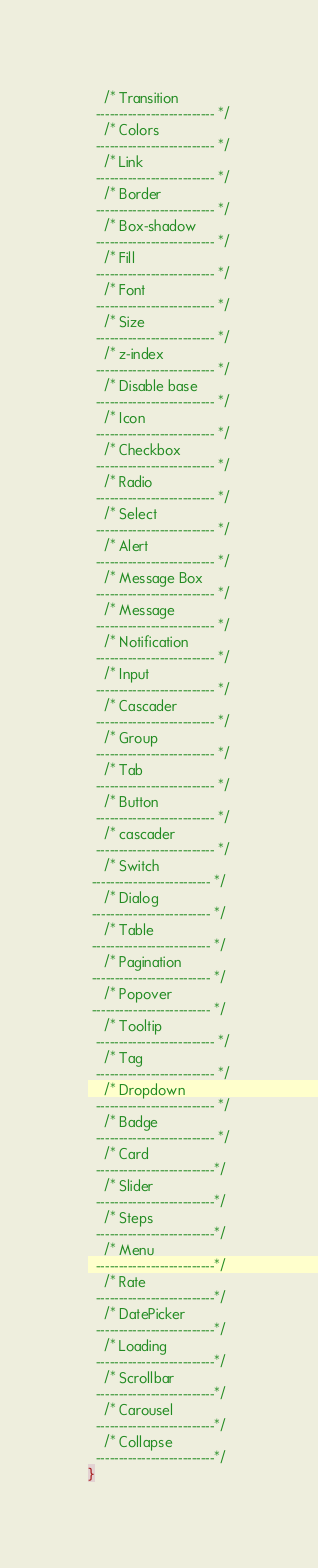Convert code to text. <code><loc_0><loc_0><loc_500><loc_500><_CSS_>    /* Transition
  -------------------------- */
    /* Colors
  -------------------------- */
    /* Link
  -------------------------- */
    /* Border
  -------------------------- */
    /* Box-shadow
  -------------------------- */
    /* Fill
  -------------------------- */
    /* Font
  -------------------------- */
    /* Size
  -------------------------- */
    /* z-index
  -------------------------- */
    /* Disable base
  -------------------------- */
    /* Icon
  -------------------------- */
    /* Checkbox
  -------------------------- */
    /* Radio
  -------------------------- */
    /* Select
  -------------------------- */
    /* Alert
  -------------------------- */
    /* Message Box
  -------------------------- */
    /* Message
  -------------------------- */
    /* Notification
  -------------------------- */
    /* Input
  -------------------------- */
    /* Cascader
  -------------------------- */
    /* Group
  -------------------------- */
    /* Tab
  -------------------------- */
    /* Button
  -------------------------- */
    /* cascader
  -------------------------- */
    /* Switch
 -------------------------- */
    /* Dialog
 -------------------------- */
    /* Table
 -------------------------- */
    /* Pagination
 -------------------------- */
    /* Popover
 -------------------------- */
    /* Tooltip
  -------------------------- */
    /* Tag
  -------------------------- */
    /* Dropdown
  -------------------------- */
    /* Badge
  -------------------------- */
    /* Card
  --------------------------*/
    /* Slider
  --------------------------*/
    /* Steps
  --------------------------*/
    /* Menu
  --------------------------*/
    /* Rate
  --------------------------*/
    /* DatePicker
  --------------------------*/
    /* Loading
  --------------------------*/
    /* Scrollbar
  --------------------------*/
    /* Carousel
  --------------------------*/
    /* Collapse
  --------------------------*/
}</code> 